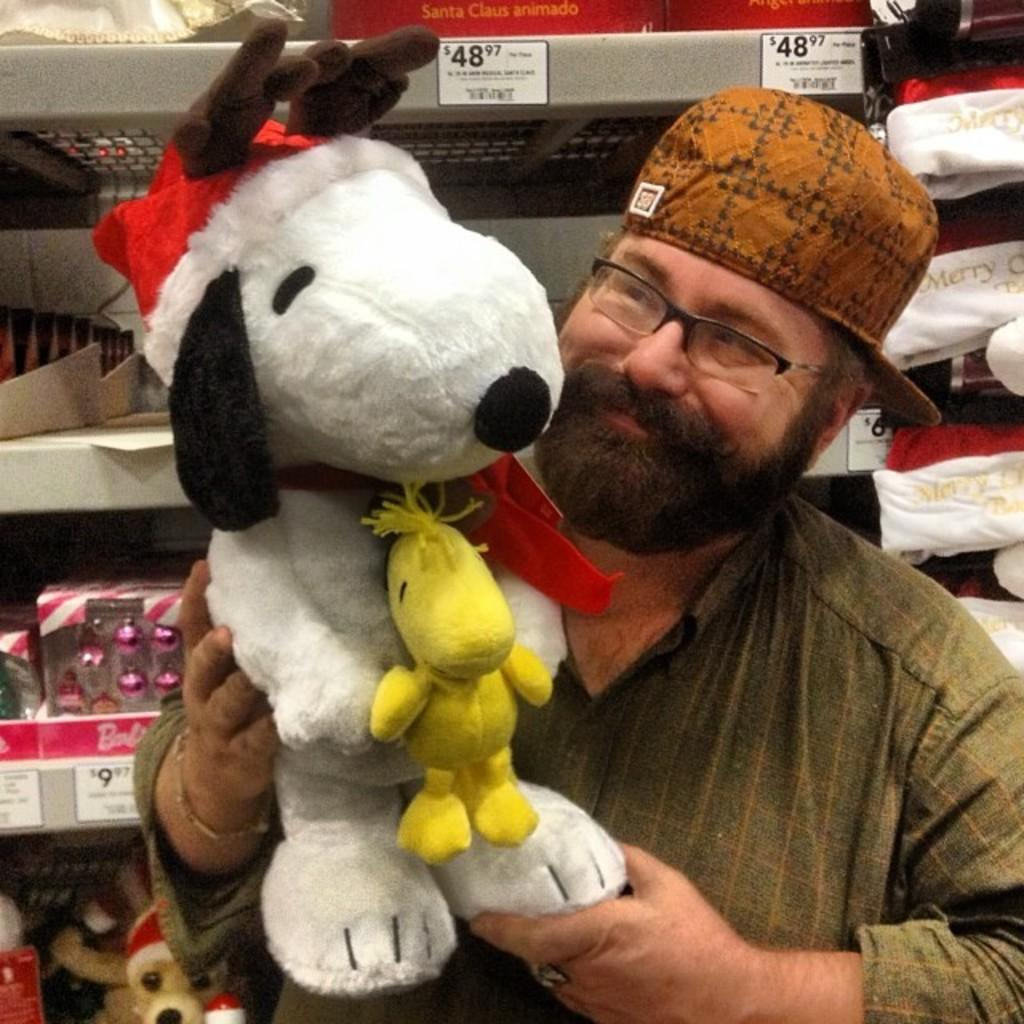What is the main subject of the image? There is a person in the image. What is the person wearing on their head? The person is wearing a cap. What is the person holding in the image? The person is holding a doll. Can you describe the color of the doll? The doll is white and yellow in color. What else can be seen in the image besides the person and the doll? There are other objects visible behind the person. How many snakes are wrapped around the person's neck in the image? There are no snakes present in the image; the person is holding a doll. 